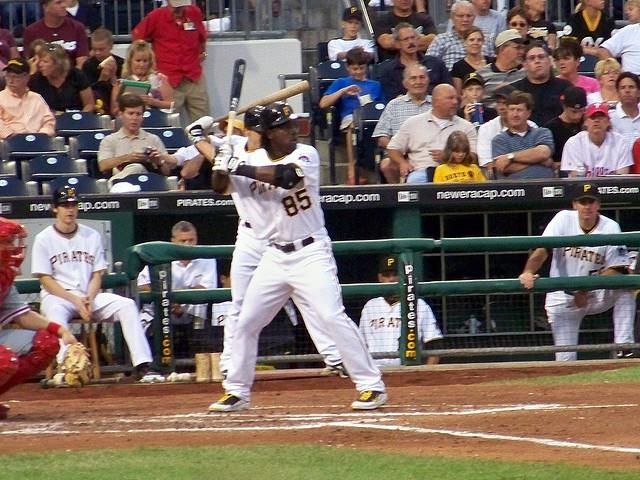What color is the batter's uniform?
Write a very short answer. White. What team is playing?
Write a very short answer. Pirates. What team is the hitter on?
Short answer required. Pirates. What number is this player?
Quick response, please. 85. 